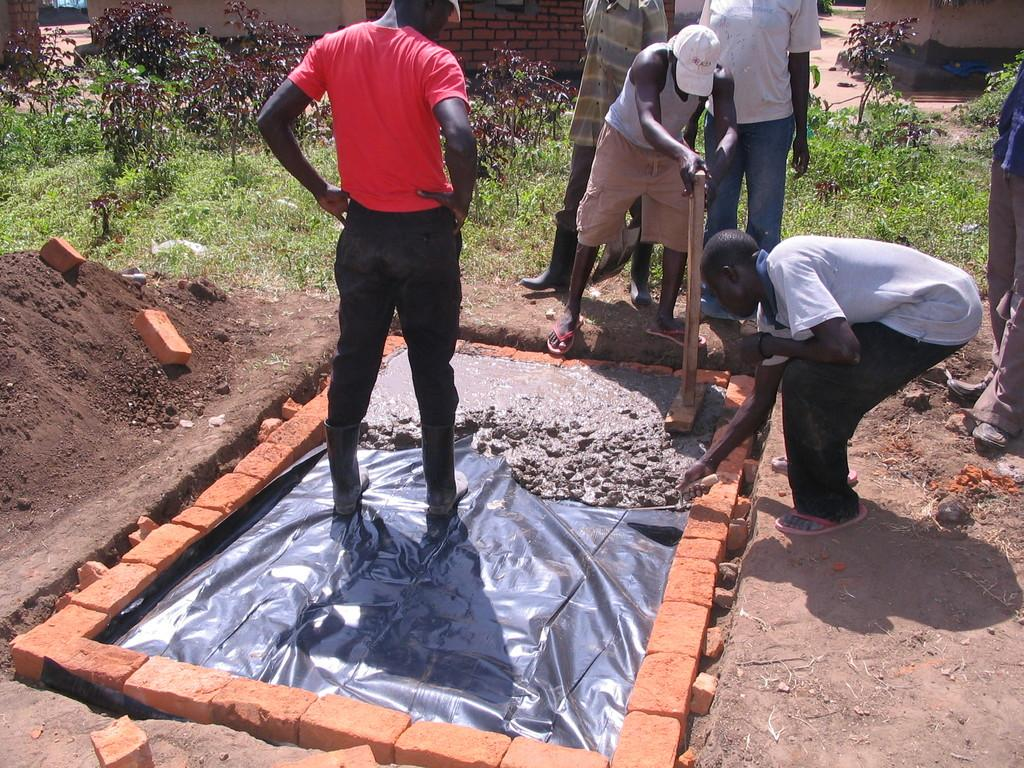What is the primary location of the people in the image? The people are on the ground in the image. What type of material is visible in the image? Bricks are visible in the image. What is covering the objects in the image? A sheet is present in the image. What type of surface is visible in the image? Soil is visible in the image. What can be found in the image besides the people and the sheet? There are objects in the image. What can be seen in the background of the image? Plants and a wall are visible in the background of the image, along with additional objects. What type of wave can be seen crashing on the shore in the image? There is no wave or shore present in the image; it features people, bricks, a sheet, soil, and objects on the ground. What is the cannon used for in the image? There is no cannon present in the image. 